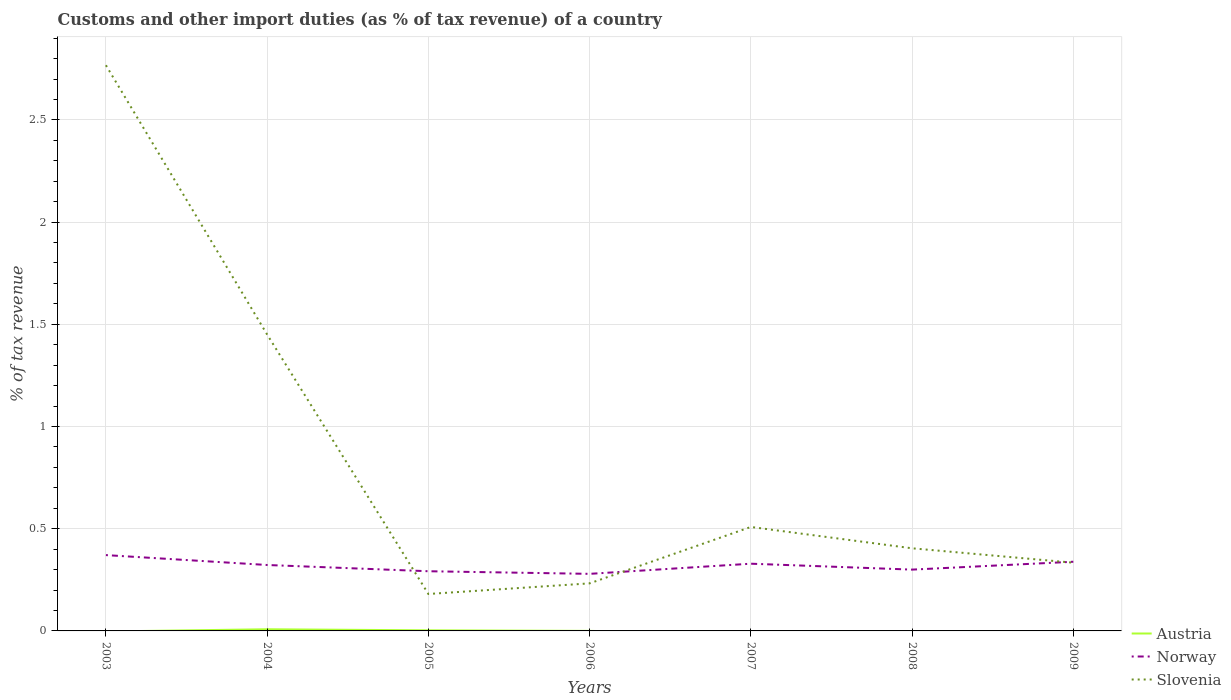How many different coloured lines are there?
Provide a succinct answer. 3. Does the line corresponding to Slovenia intersect with the line corresponding to Norway?
Offer a terse response. Yes. Across all years, what is the maximum percentage of tax revenue from customs in Norway?
Offer a terse response. 0.28. What is the total percentage of tax revenue from customs in Slovenia in the graph?
Offer a very short reply. 0.07. What is the difference between the highest and the second highest percentage of tax revenue from customs in Norway?
Your answer should be compact. 0.09. What is the difference between the highest and the lowest percentage of tax revenue from customs in Norway?
Ensure brevity in your answer.  4. Where does the legend appear in the graph?
Your answer should be very brief. Bottom right. What is the title of the graph?
Give a very brief answer. Customs and other import duties (as % of tax revenue) of a country. Does "Uzbekistan" appear as one of the legend labels in the graph?
Ensure brevity in your answer.  No. What is the label or title of the Y-axis?
Offer a terse response. % of tax revenue. What is the % of tax revenue of Austria in 2003?
Provide a short and direct response. 0. What is the % of tax revenue in Norway in 2003?
Keep it short and to the point. 0.37. What is the % of tax revenue of Slovenia in 2003?
Ensure brevity in your answer.  2.77. What is the % of tax revenue of Austria in 2004?
Provide a short and direct response. 0.01. What is the % of tax revenue in Norway in 2004?
Offer a very short reply. 0.32. What is the % of tax revenue of Slovenia in 2004?
Ensure brevity in your answer.  1.45. What is the % of tax revenue of Austria in 2005?
Your answer should be compact. 0. What is the % of tax revenue of Norway in 2005?
Ensure brevity in your answer.  0.29. What is the % of tax revenue in Slovenia in 2005?
Ensure brevity in your answer.  0.18. What is the % of tax revenue in Austria in 2006?
Give a very brief answer. 0. What is the % of tax revenue of Norway in 2006?
Ensure brevity in your answer.  0.28. What is the % of tax revenue in Slovenia in 2006?
Your response must be concise. 0.23. What is the % of tax revenue of Norway in 2007?
Your response must be concise. 0.33. What is the % of tax revenue of Slovenia in 2007?
Give a very brief answer. 0.51. What is the % of tax revenue in Austria in 2008?
Your answer should be compact. 0. What is the % of tax revenue in Norway in 2008?
Provide a short and direct response. 0.3. What is the % of tax revenue in Slovenia in 2008?
Provide a succinct answer. 0.4. What is the % of tax revenue in Austria in 2009?
Your answer should be very brief. 0. What is the % of tax revenue in Norway in 2009?
Keep it short and to the point. 0.34. What is the % of tax revenue of Slovenia in 2009?
Ensure brevity in your answer.  0.33. Across all years, what is the maximum % of tax revenue of Austria?
Provide a succinct answer. 0.01. Across all years, what is the maximum % of tax revenue of Norway?
Keep it short and to the point. 0.37. Across all years, what is the maximum % of tax revenue of Slovenia?
Offer a very short reply. 2.77. Across all years, what is the minimum % of tax revenue of Norway?
Provide a short and direct response. 0.28. Across all years, what is the minimum % of tax revenue of Slovenia?
Offer a very short reply. 0.18. What is the total % of tax revenue of Austria in the graph?
Your response must be concise. 0.01. What is the total % of tax revenue of Norway in the graph?
Provide a short and direct response. 2.23. What is the total % of tax revenue of Slovenia in the graph?
Ensure brevity in your answer.  5.88. What is the difference between the % of tax revenue of Norway in 2003 and that in 2004?
Make the answer very short. 0.05. What is the difference between the % of tax revenue in Slovenia in 2003 and that in 2004?
Keep it short and to the point. 1.32. What is the difference between the % of tax revenue of Norway in 2003 and that in 2005?
Ensure brevity in your answer.  0.08. What is the difference between the % of tax revenue of Slovenia in 2003 and that in 2005?
Provide a short and direct response. 2.59. What is the difference between the % of tax revenue of Norway in 2003 and that in 2006?
Provide a succinct answer. 0.09. What is the difference between the % of tax revenue in Slovenia in 2003 and that in 2006?
Provide a succinct answer. 2.53. What is the difference between the % of tax revenue of Norway in 2003 and that in 2007?
Give a very brief answer. 0.04. What is the difference between the % of tax revenue in Slovenia in 2003 and that in 2007?
Offer a terse response. 2.26. What is the difference between the % of tax revenue of Norway in 2003 and that in 2008?
Ensure brevity in your answer.  0.07. What is the difference between the % of tax revenue in Slovenia in 2003 and that in 2008?
Offer a very short reply. 2.36. What is the difference between the % of tax revenue in Norway in 2003 and that in 2009?
Offer a terse response. 0.03. What is the difference between the % of tax revenue of Slovenia in 2003 and that in 2009?
Make the answer very short. 2.43. What is the difference between the % of tax revenue in Austria in 2004 and that in 2005?
Ensure brevity in your answer.  0.01. What is the difference between the % of tax revenue of Norway in 2004 and that in 2005?
Provide a succinct answer. 0.03. What is the difference between the % of tax revenue in Slovenia in 2004 and that in 2005?
Give a very brief answer. 1.27. What is the difference between the % of tax revenue of Austria in 2004 and that in 2006?
Provide a succinct answer. 0.01. What is the difference between the % of tax revenue of Norway in 2004 and that in 2006?
Provide a succinct answer. 0.04. What is the difference between the % of tax revenue of Slovenia in 2004 and that in 2006?
Offer a very short reply. 1.22. What is the difference between the % of tax revenue in Norway in 2004 and that in 2007?
Offer a very short reply. -0.01. What is the difference between the % of tax revenue in Slovenia in 2004 and that in 2007?
Your answer should be compact. 0.94. What is the difference between the % of tax revenue in Norway in 2004 and that in 2008?
Your answer should be very brief. 0.02. What is the difference between the % of tax revenue in Slovenia in 2004 and that in 2008?
Make the answer very short. 1.05. What is the difference between the % of tax revenue in Austria in 2004 and that in 2009?
Offer a very short reply. 0.01. What is the difference between the % of tax revenue in Norway in 2004 and that in 2009?
Give a very brief answer. -0.02. What is the difference between the % of tax revenue in Slovenia in 2004 and that in 2009?
Make the answer very short. 1.12. What is the difference between the % of tax revenue in Austria in 2005 and that in 2006?
Keep it short and to the point. 0. What is the difference between the % of tax revenue in Norway in 2005 and that in 2006?
Offer a very short reply. 0.01. What is the difference between the % of tax revenue in Slovenia in 2005 and that in 2006?
Give a very brief answer. -0.05. What is the difference between the % of tax revenue in Norway in 2005 and that in 2007?
Your response must be concise. -0.04. What is the difference between the % of tax revenue in Slovenia in 2005 and that in 2007?
Your answer should be very brief. -0.33. What is the difference between the % of tax revenue of Norway in 2005 and that in 2008?
Offer a very short reply. -0.01. What is the difference between the % of tax revenue of Slovenia in 2005 and that in 2008?
Offer a terse response. -0.22. What is the difference between the % of tax revenue in Austria in 2005 and that in 2009?
Keep it short and to the point. 0. What is the difference between the % of tax revenue of Norway in 2005 and that in 2009?
Ensure brevity in your answer.  -0.05. What is the difference between the % of tax revenue in Slovenia in 2005 and that in 2009?
Make the answer very short. -0.15. What is the difference between the % of tax revenue of Norway in 2006 and that in 2007?
Provide a succinct answer. -0.05. What is the difference between the % of tax revenue of Slovenia in 2006 and that in 2007?
Give a very brief answer. -0.28. What is the difference between the % of tax revenue of Norway in 2006 and that in 2008?
Your answer should be compact. -0.02. What is the difference between the % of tax revenue in Slovenia in 2006 and that in 2008?
Your answer should be compact. -0.17. What is the difference between the % of tax revenue of Norway in 2006 and that in 2009?
Make the answer very short. -0.06. What is the difference between the % of tax revenue of Slovenia in 2006 and that in 2009?
Offer a very short reply. -0.1. What is the difference between the % of tax revenue of Norway in 2007 and that in 2008?
Your answer should be very brief. 0.03. What is the difference between the % of tax revenue of Slovenia in 2007 and that in 2008?
Your response must be concise. 0.1. What is the difference between the % of tax revenue in Norway in 2007 and that in 2009?
Your answer should be compact. -0.01. What is the difference between the % of tax revenue in Slovenia in 2007 and that in 2009?
Your answer should be compact. 0.17. What is the difference between the % of tax revenue of Norway in 2008 and that in 2009?
Offer a terse response. -0.04. What is the difference between the % of tax revenue in Slovenia in 2008 and that in 2009?
Provide a succinct answer. 0.07. What is the difference between the % of tax revenue in Norway in 2003 and the % of tax revenue in Slovenia in 2004?
Offer a terse response. -1.08. What is the difference between the % of tax revenue in Norway in 2003 and the % of tax revenue in Slovenia in 2005?
Keep it short and to the point. 0.19. What is the difference between the % of tax revenue of Norway in 2003 and the % of tax revenue of Slovenia in 2006?
Provide a short and direct response. 0.14. What is the difference between the % of tax revenue of Norway in 2003 and the % of tax revenue of Slovenia in 2007?
Your answer should be compact. -0.14. What is the difference between the % of tax revenue in Norway in 2003 and the % of tax revenue in Slovenia in 2008?
Provide a short and direct response. -0.03. What is the difference between the % of tax revenue of Norway in 2003 and the % of tax revenue of Slovenia in 2009?
Provide a succinct answer. 0.04. What is the difference between the % of tax revenue of Austria in 2004 and the % of tax revenue of Norway in 2005?
Provide a short and direct response. -0.28. What is the difference between the % of tax revenue of Austria in 2004 and the % of tax revenue of Slovenia in 2005?
Ensure brevity in your answer.  -0.17. What is the difference between the % of tax revenue in Norway in 2004 and the % of tax revenue in Slovenia in 2005?
Provide a short and direct response. 0.14. What is the difference between the % of tax revenue in Austria in 2004 and the % of tax revenue in Norway in 2006?
Make the answer very short. -0.27. What is the difference between the % of tax revenue of Austria in 2004 and the % of tax revenue of Slovenia in 2006?
Your answer should be compact. -0.22. What is the difference between the % of tax revenue of Norway in 2004 and the % of tax revenue of Slovenia in 2006?
Your response must be concise. 0.09. What is the difference between the % of tax revenue of Austria in 2004 and the % of tax revenue of Norway in 2007?
Offer a very short reply. -0.32. What is the difference between the % of tax revenue in Austria in 2004 and the % of tax revenue in Slovenia in 2007?
Give a very brief answer. -0.5. What is the difference between the % of tax revenue of Norway in 2004 and the % of tax revenue of Slovenia in 2007?
Your response must be concise. -0.19. What is the difference between the % of tax revenue of Austria in 2004 and the % of tax revenue of Norway in 2008?
Make the answer very short. -0.29. What is the difference between the % of tax revenue of Austria in 2004 and the % of tax revenue of Slovenia in 2008?
Your answer should be very brief. -0.4. What is the difference between the % of tax revenue of Norway in 2004 and the % of tax revenue of Slovenia in 2008?
Your answer should be compact. -0.08. What is the difference between the % of tax revenue in Austria in 2004 and the % of tax revenue in Norway in 2009?
Ensure brevity in your answer.  -0.33. What is the difference between the % of tax revenue in Austria in 2004 and the % of tax revenue in Slovenia in 2009?
Offer a very short reply. -0.33. What is the difference between the % of tax revenue of Norway in 2004 and the % of tax revenue of Slovenia in 2009?
Your answer should be compact. -0.01. What is the difference between the % of tax revenue in Austria in 2005 and the % of tax revenue in Norway in 2006?
Your answer should be compact. -0.28. What is the difference between the % of tax revenue of Austria in 2005 and the % of tax revenue of Slovenia in 2006?
Provide a short and direct response. -0.23. What is the difference between the % of tax revenue of Norway in 2005 and the % of tax revenue of Slovenia in 2006?
Offer a terse response. 0.06. What is the difference between the % of tax revenue in Austria in 2005 and the % of tax revenue in Norway in 2007?
Give a very brief answer. -0.33. What is the difference between the % of tax revenue in Austria in 2005 and the % of tax revenue in Slovenia in 2007?
Provide a short and direct response. -0.51. What is the difference between the % of tax revenue in Norway in 2005 and the % of tax revenue in Slovenia in 2007?
Provide a short and direct response. -0.22. What is the difference between the % of tax revenue in Austria in 2005 and the % of tax revenue in Norway in 2008?
Provide a succinct answer. -0.3. What is the difference between the % of tax revenue in Austria in 2005 and the % of tax revenue in Slovenia in 2008?
Provide a short and direct response. -0.4. What is the difference between the % of tax revenue in Norway in 2005 and the % of tax revenue in Slovenia in 2008?
Ensure brevity in your answer.  -0.11. What is the difference between the % of tax revenue of Austria in 2005 and the % of tax revenue of Norway in 2009?
Make the answer very short. -0.34. What is the difference between the % of tax revenue of Austria in 2005 and the % of tax revenue of Slovenia in 2009?
Give a very brief answer. -0.33. What is the difference between the % of tax revenue in Norway in 2005 and the % of tax revenue in Slovenia in 2009?
Ensure brevity in your answer.  -0.04. What is the difference between the % of tax revenue of Austria in 2006 and the % of tax revenue of Norway in 2007?
Make the answer very short. -0.33. What is the difference between the % of tax revenue in Austria in 2006 and the % of tax revenue in Slovenia in 2007?
Offer a terse response. -0.51. What is the difference between the % of tax revenue of Norway in 2006 and the % of tax revenue of Slovenia in 2007?
Your answer should be compact. -0.23. What is the difference between the % of tax revenue in Austria in 2006 and the % of tax revenue in Norway in 2008?
Give a very brief answer. -0.3. What is the difference between the % of tax revenue of Austria in 2006 and the % of tax revenue of Slovenia in 2008?
Provide a succinct answer. -0.4. What is the difference between the % of tax revenue in Norway in 2006 and the % of tax revenue in Slovenia in 2008?
Keep it short and to the point. -0.12. What is the difference between the % of tax revenue in Austria in 2006 and the % of tax revenue in Norway in 2009?
Provide a succinct answer. -0.34. What is the difference between the % of tax revenue of Austria in 2006 and the % of tax revenue of Slovenia in 2009?
Provide a succinct answer. -0.33. What is the difference between the % of tax revenue in Norway in 2006 and the % of tax revenue in Slovenia in 2009?
Make the answer very short. -0.05. What is the difference between the % of tax revenue of Norway in 2007 and the % of tax revenue of Slovenia in 2008?
Offer a terse response. -0.08. What is the difference between the % of tax revenue in Norway in 2007 and the % of tax revenue in Slovenia in 2009?
Give a very brief answer. -0. What is the difference between the % of tax revenue in Norway in 2008 and the % of tax revenue in Slovenia in 2009?
Provide a short and direct response. -0.03. What is the average % of tax revenue in Austria per year?
Offer a very short reply. 0. What is the average % of tax revenue of Norway per year?
Provide a short and direct response. 0.32. What is the average % of tax revenue of Slovenia per year?
Offer a very short reply. 0.84. In the year 2003, what is the difference between the % of tax revenue of Norway and % of tax revenue of Slovenia?
Give a very brief answer. -2.4. In the year 2004, what is the difference between the % of tax revenue in Austria and % of tax revenue in Norway?
Provide a succinct answer. -0.31. In the year 2004, what is the difference between the % of tax revenue in Austria and % of tax revenue in Slovenia?
Give a very brief answer. -1.44. In the year 2004, what is the difference between the % of tax revenue of Norway and % of tax revenue of Slovenia?
Give a very brief answer. -1.13. In the year 2005, what is the difference between the % of tax revenue in Austria and % of tax revenue in Norway?
Offer a very short reply. -0.29. In the year 2005, what is the difference between the % of tax revenue in Austria and % of tax revenue in Slovenia?
Make the answer very short. -0.18. In the year 2005, what is the difference between the % of tax revenue in Norway and % of tax revenue in Slovenia?
Ensure brevity in your answer.  0.11. In the year 2006, what is the difference between the % of tax revenue in Austria and % of tax revenue in Norway?
Your answer should be very brief. -0.28. In the year 2006, what is the difference between the % of tax revenue in Austria and % of tax revenue in Slovenia?
Provide a short and direct response. -0.23. In the year 2006, what is the difference between the % of tax revenue in Norway and % of tax revenue in Slovenia?
Ensure brevity in your answer.  0.05. In the year 2007, what is the difference between the % of tax revenue in Norway and % of tax revenue in Slovenia?
Make the answer very short. -0.18. In the year 2008, what is the difference between the % of tax revenue of Norway and % of tax revenue of Slovenia?
Your answer should be compact. -0.1. In the year 2009, what is the difference between the % of tax revenue of Austria and % of tax revenue of Norway?
Your answer should be compact. -0.34. In the year 2009, what is the difference between the % of tax revenue in Austria and % of tax revenue in Slovenia?
Your answer should be very brief. -0.33. In the year 2009, what is the difference between the % of tax revenue of Norway and % of tax revenue of Slovenia?
Your answer should be compact. 0. What is the ratio of the % of tax revenue in Norway in 2003 to that in 2004?
Your response must be concise. 1.15. What is the ratio of the % of tax revenue of Slovenia in 2003 to that in 2004?
Ensure brevity in your answer.  1.91. What is the ratio of the % of tax revenue of Norway in 2003 to that in 2005?
Offer a very short reply. 1.27. What is the ratio of the % of tax revenue of Slovenia in 2003 to that in 2005?
Keep it short and to the point. 15.31. What is the ratio of the % of tax revenue of Norway in 2003 to that in 2006?
Give a very brief answer. 1.33. What is the ratio of the % of tax revenue in Slovenia in 2003 to that in 2006?
Provide a short and direct response. 11.89. What is the ratio of the % of tax revenue in Norway in 2003 to that in 2007?
Keep it short and to the point. 1.13. What is the ratio of the % of tax revenue of Slovenia in 2003 to that in 2007?
Provide a succinct answer. 5.44. What is the ratio of the % of tax revenue of Norway in 2003 to that in 2008?
Give a very brief answer. 1.24. What is the ratio of the % of tax revenue of Slovenia in 2003 to that in 2008?
Provide a short and direct response. 6.85. What is the ratio of the % of tax revenue of Norway in 2003 to that in 2009?
Your response must be concise. 1.1. What is the ratio of the % of tax revenue in Slovenia in 2003 to that in 2009?
Your answer should be very brief. 8.29. What is the ratio of the % of tax revenue in Austria in 2004 to that in 2005?
Give a very brief answer. 2.78. What is the ratio of the % of tax revenue in Norway in 2004 to that in 2005?
Your response must be concise. 1.1. What is the ratio of the % of tax revenue in Slovenia in 2004 to that in 2005?
Ensure brevity in your answer.  8.02. What is the ratio of the % of tax revenue of Austria in 2004 to that in 2006?
Make the answer very short. 58.81. What is the ratio of the % of tax revenue of Norway in 2004 to that in 2006?
Make the answer very short. 1.16. What is the ratio of the % of tax revenue in Slovenia in 2004 to that in 2006?
Your answer should be compact. 6.23. What is the ratio of the % of tax revenue of Norway in 2004 to that in 2007?
Your response must be concise. 0.98. What is the ratio of the % of tax revenue in Slovenia in 2004 to that in 2007?
Offer a terse response. 2.85. What is the ratio of the % of tax revenue in Norway in 2004 to that in 2008?
Offer a very short reply. 1.08. What is the ratio of the % of tax revenue in Slovenia in 2004 to that in 2008?
Provide a short and direct response. 3.59. What is the ratio of the % of tax revenue in Austria in 2004 to that in 2009?
Your response must be concise. 59.24. What is the ratio of the % of tax revenue of Norway in 2004 to that in 2009?
Offer a terse response. 0.95. What is the ratio of the % of tax revenue in Slovenia in 2004 to that in 2009?
Give a very brief answer. 4.34. What is the ratio of the % of tax revenue in Austria in 2005 to that in 2006?
Keep it short and to the point. 21.14. What is the ratio of the % of tax revenue of Norway in 2005 to that in 2006?
Make the answer very short. 1.05. What is the ratio of the % of tax revenue of Slovenia in 2005 to that in 2006?
Make the answer very short. 0.78. What is the ratio of the % of tax revenue of Norway in 2005 to that in 2007?
Keep it short and to the point. 0.89. What is the ratio of the % of tax revenue in Slovenia in 2005 to that in 2007?
Ensure brevity in your answer.  0.36. What is the ratio of the % of tax revenue in Norway in 2005 to that in 2008?
Give a very brief answer. 0.97. What is the ratio of the % of tax revenue in Slovenia in 2005 to that in 2008?
Ensure brevity in your answer.  0.45. What is the ratio of the % of tax revenue in Austria in 2005 to that in 2009?
Provide a succinct answer. 21.29. What is the ratio of the % of tax revenue of Norway in 2005 to that in 2009?
Your answer should be compact. 0.86. What is the ratio of the % of tax revenue in Slovenia in 2005 to that in 2009?
Ensure brevity in your answer.  0.54. What is the ratio of the % of tax revenue of Norway in 2006 to that in 2007?
Your response must be concise. 0.85. What is the ratio of the % of tax revenue in Slovenia in 2006 to that in 2007?
Provide a succinct answer. 0.46. What is the ratio of the % of tax revenue in Norway in 2006 to that in 2008?
Keep it short and to the point. 0.93. What is the ratio of the % of tax revenue in Slovenia in 2006 to that in 2008?
Your answer should be compact. 0.58. What is the ratio of the % of tax revenue in Austria in 2006 to that in 2009?
Ensure brevity in your answer.  1.01. What is the ratio of the % of tax revenue of Norway in 2006 to that in 2009?
Provide a succinct answer. 0.82. What is the ratio of the % of tax revenue of Slovenia in 2006 to that in 2009?
Ensure brevity in your answer.  0.7. What is the ratio of the % of tax revenue of Norway in 2007 to that in 2008?
Make the answer very short. 1.1. What is the ratio of the % of tax revenue in Slovenia in 2007 to that in 2008?
Provide a short and direct response. 1.26. What is the ratio of the % of tax revenue in Norway in 2007 to that in 2009?
Make the answer very short. 0.97. What is the ratio of the % of tax revenue of Slovenia in 2007 to that in 2009?
Provide a succinct answer. 1.52. What is the ratio of the % of tax revenue in Norway in 2008 to that in 2009?
Provide a succinct answer. 0.89. What is the ratio of the % of tax revenue of Slovenia in 2008 to that in 2009?
Keep it short and to the point. 1.21. What is the difference between the highest and the second highest % of tax revenue in Austria?
Give a very brief answer. 0.01. What is the difference between the highest and the second highest % of tax revenue of Norway?
Offer a very short reply. 0.03. What is the difference between the highest and the second highest % of tax revenue in Slovenia?
Keep it short and to the point. 1.32. What is the difference between the highest and the lowest % of tax revenue in Austria?
Your response must be concise. 0.01. What is the difference between the highest and the lowest % of tax revenue in Norway?
Your answer should be very brief. 0.09. What is the difference between the highest and the lowest % of tax revenue of Slovenia?
Give a very brief answer. 2.59. 